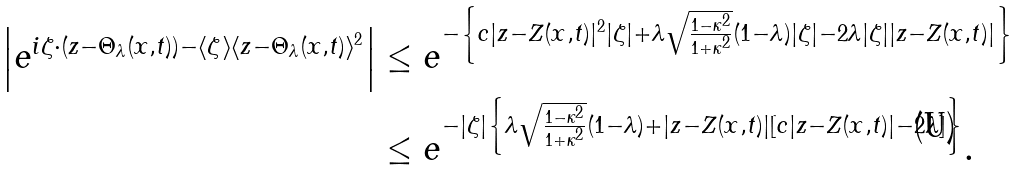<formula> <loc_0><loc_0><loc_500><loc_500>\left | e ^ { i \zeta \cdot ( z - \Theta _ { \lambda } ( x , t ) ) - \langle \zeta \rangle \langle z - \Theta _ { \lambda } ( x , t ) \rangle ^ { 2 } } \right | & \leq e ^ { - \left \{ c | z - Z ( x , t ) | ^ { 2 } | \zeta | + \lambda \sqrt { \frac { 1 - \kappa ^ { 2 } } { 1 + \kappa ^ { 2 } } } ( 1 - \lambda ) | \zeta | - 2 \lambda | \zeta | | z - Z ( x , t ) | \right \} } \\ & \leq e ^ { - | \zeta | \left \{ \lambda \sqrt { \frac { 1 - \kappa ^ { 2 } } { 1 + \kappa ^ { 2 } } } ( 1 - \lambda ) + | z - Z ( x , t ) | \left [ c | z - Z ( x , t ) | - 2 \lambda \right ] \right \} } .</formula> 